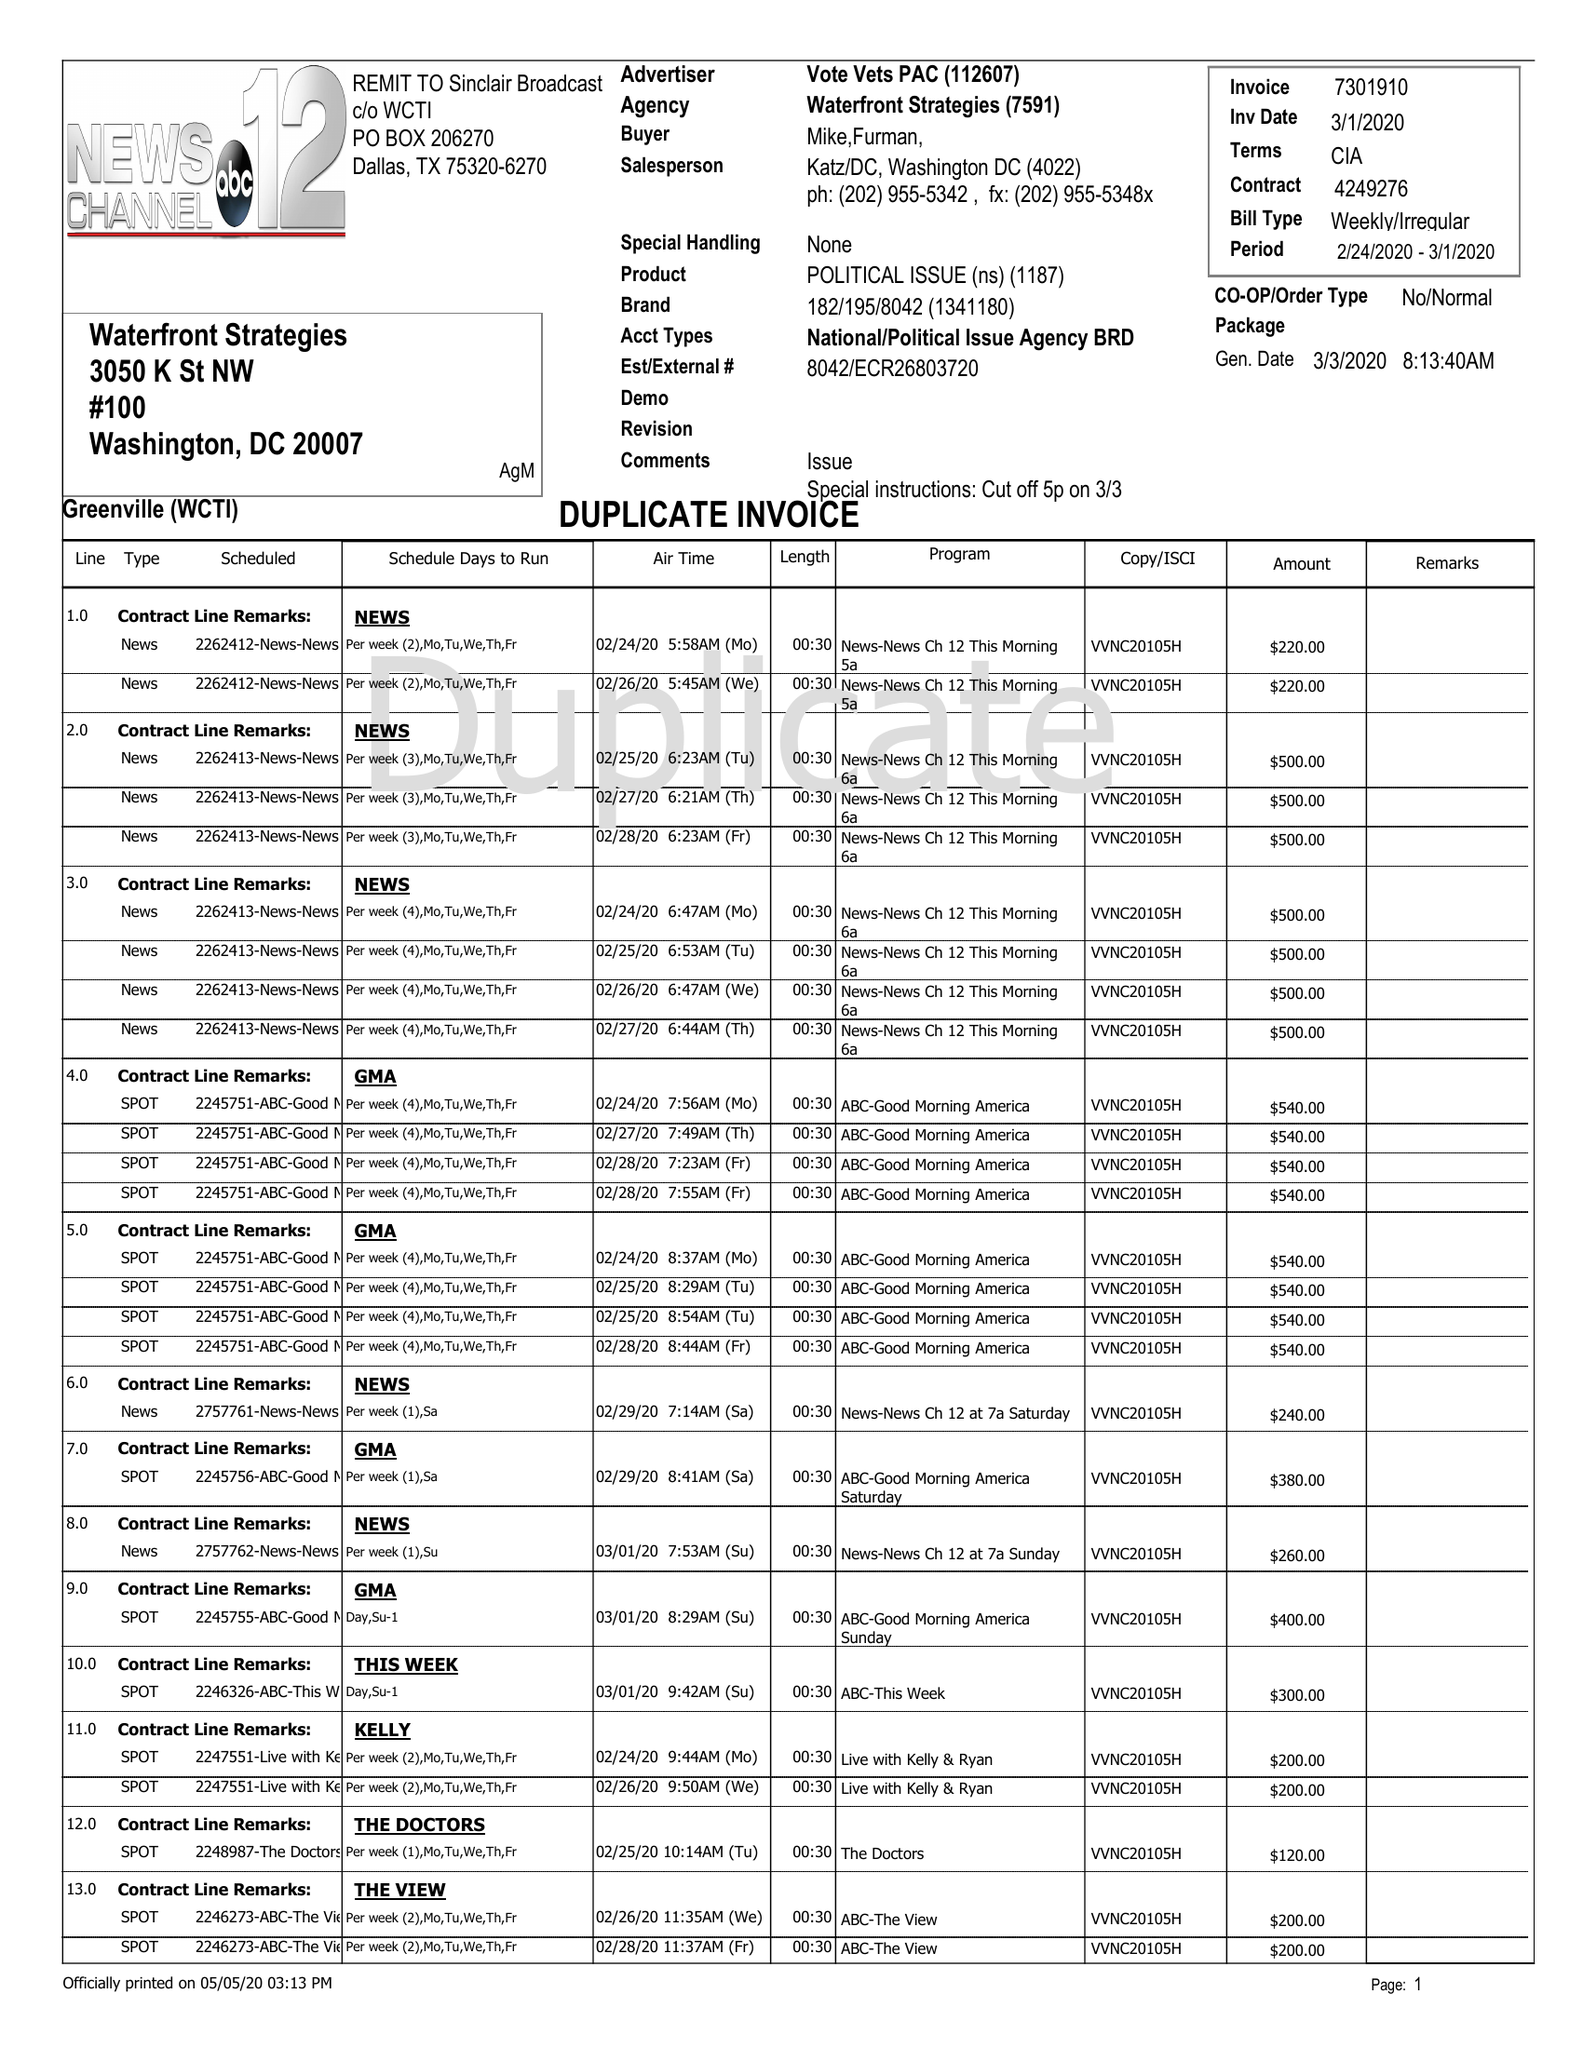What is the value for the flight_from?
Answer the question using a single word or phrase. 02/24/20 